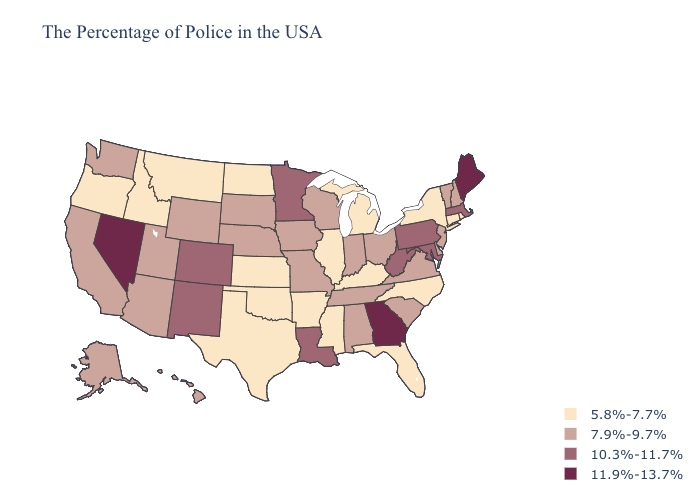Does New Hampshire have the same value as Washington?
Answer briefly. Yes. Among the states that border Vermont , which have the highest value?
Short answer required. Massachusetts. Name the states that have a value in the range 10.3%-11.7%?
Quick response, please. Massachusetts, Maryland, Pennsylvania, West Virginia, Louisiana, Minnesota, Colorado, New Mexico. What is the lowest value in the West?
Be succinct. 5.8%-7.7%. Name the states that have a value in the range 11.9%-13.7%?
Concise answer only. Maine, Georgia, Nevada. Name the states that have a value in the range 11.9%-13.7%?
Write a very short answer. Maine, Georgia, Nevada. What is the value of New Jersey?
Answer briefly. 7.9%-9.7%. Does Kansas have the same value as New York?
Keep it brief. Yes. What is the value of Wyoming?
Write a very short answer. 7.9%-9.7%. Does Michigan have a lower value than Idaho?
Give a very brief answer. No. What is the value of Georgia?
Short answer required. 11.9%-13.7%. What is the value of Texas?
Answer briefly. 5.8%-7.7%. What is the highest value in the USA?
Write a very short answer. 11.9%-13.7%. What is the value of Florida?
Give a very brief answer. 5.8%-7.7%. 